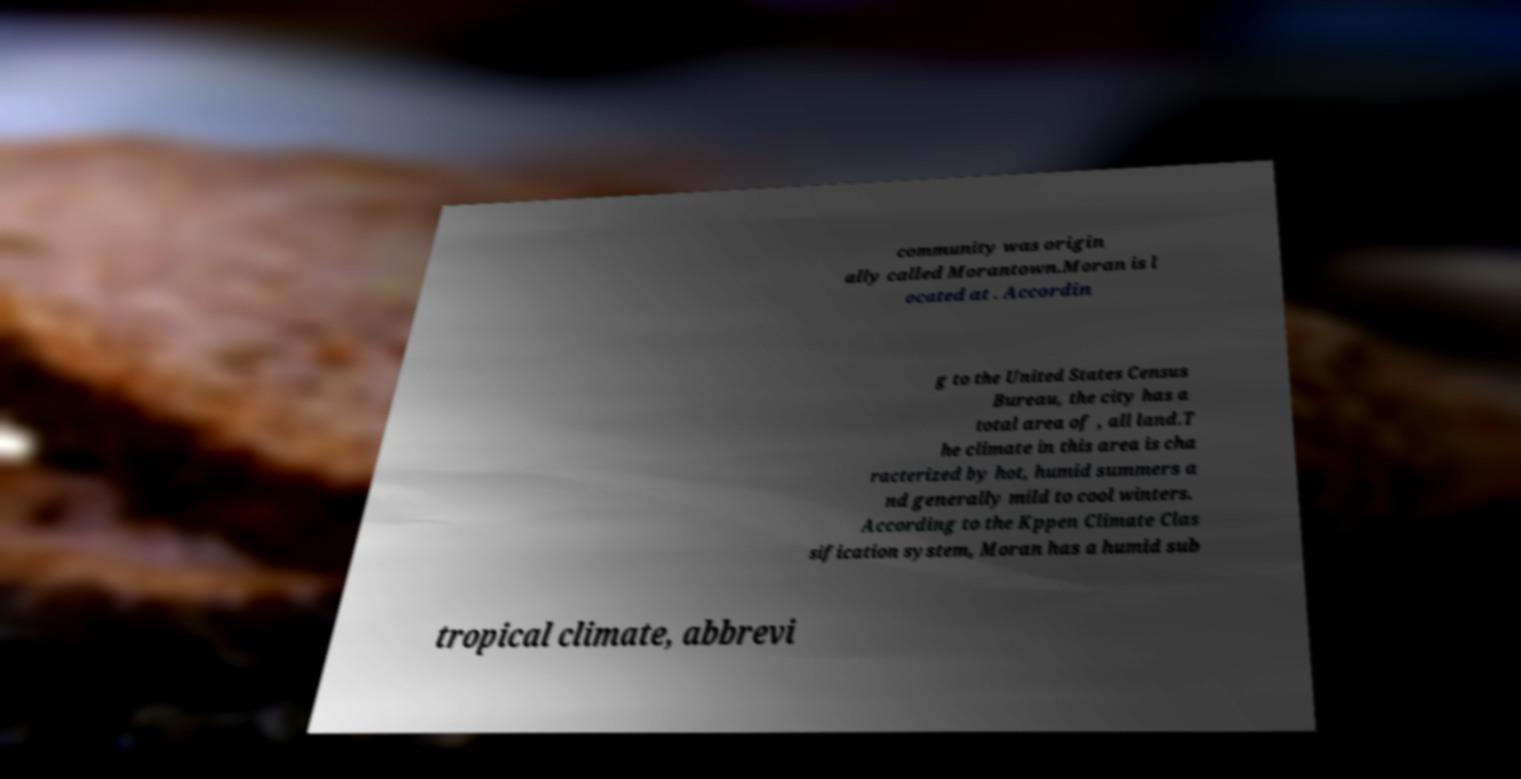What messages or text are displayed in this image? I need them in a readable, typed format. community was origin ally called Morantown.Moran is l ocated at . Accordin g to the United States Census Bureau, the city has a total area of , all land.T he climate in this area is cha racterized by hot, humid summers a nd generally mild to cool winters. According to the Kppen Climate Clas sification system, Moran has a humid sub tropical climate, abbrevi 